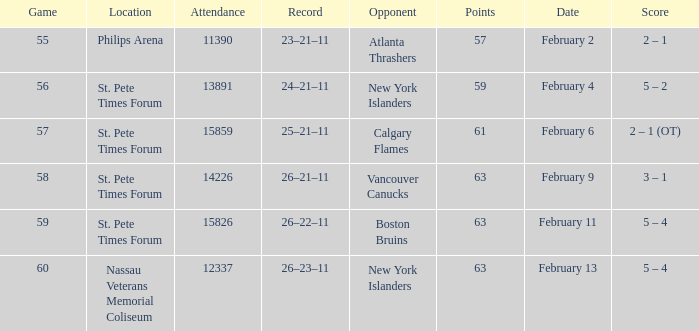What scores happened to be on February 9? 3 – 1. 